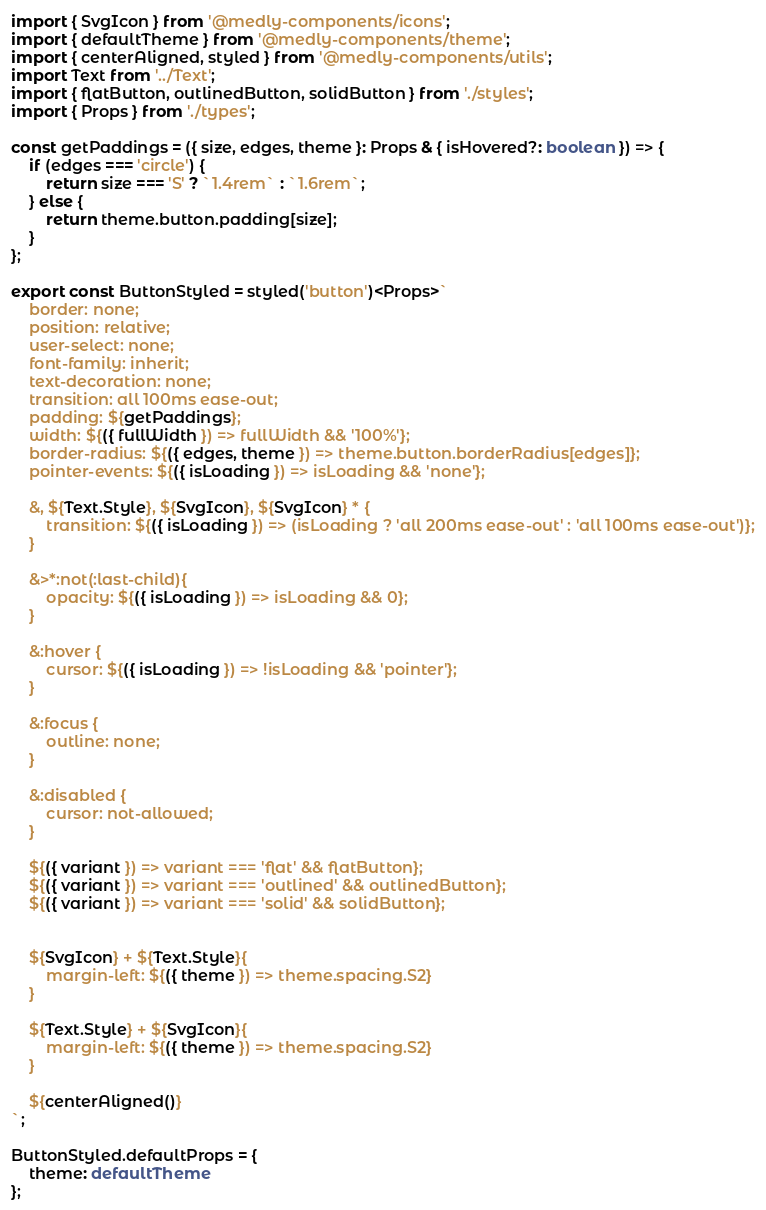<code> <loc_0><loc_0><loc_500><loc_500><_TypeScript_>import { SvgIcon } from '@medly-components/icons';
import { defaultTheme } from '@medly-components/theme';
import { centerAligned, styled } from '@medly-components/utils';
import Text from '../Text';
import { flatButton, outlinedButton, solidButton } from './styles';
import { Props } from './types';

const getPaddings = ({ size, edges, theme }: Props & { isHovered?: boolean }) => {
    if (edges === 'circle') {
        return size === 'S' ? `1.4rem` : `1.6rem`;
    } else {
        return theme.button.padding[size];
    }
};

export const ButtonStyled = styled('button')<Props>`
    border: none;
    position: relative;
    user-select: none;
    font-family: inherit;
    text-decoration: none;
    transition: all 100ms ease-out;
    padding: ${getPaddings};
    width: ${({ fullWidth }) => fullWidth && '100%'};
    border-radius: ${({ edges, theme }) => theme.button.borderRadius[edges]};
    pointer-events: ${({ isLoading }) => isLoading && 'none'};

    &, ${Text.Style}, ${SvgIcon}, ${SvgIcon} * {
        transition: ${({ isLoading }) => (isLoading ? 'all 200ms ease-out' : 'all 100ms ease-out')};
    }

    &>*:not(:last-child){
        opacity: ${({ isLoading }) => isLoading && 0};
    }

    &:hover {
        cursor: ${({ isLoading }) => !isLoading && 'pointer'};
    }

    &:focus {
        outline: none;
    }

    &:disabled {
        cursor: not-allowed;
    }

    ${({ variant }) => variant === 'flat' && flatButton};
    ${({ variant }) => variant === 'outlined' && outlinedButton};
    ${({ variant }) => variant === 'solid' && solidButton};


    ${SvgIcon} + ${Text.Style}{
        margin-left: ${({ theme }) => theme.spacing.S2}
    }

    ${Text.Style} + ${SvgIcon}{
        margin-left: ${({ theme }) => theme.spacing.S2}
    }

    ${centerAligned()}
`;

ButtonStyled.defaultProps = {
    theme: defaultTheme
};
</code> 